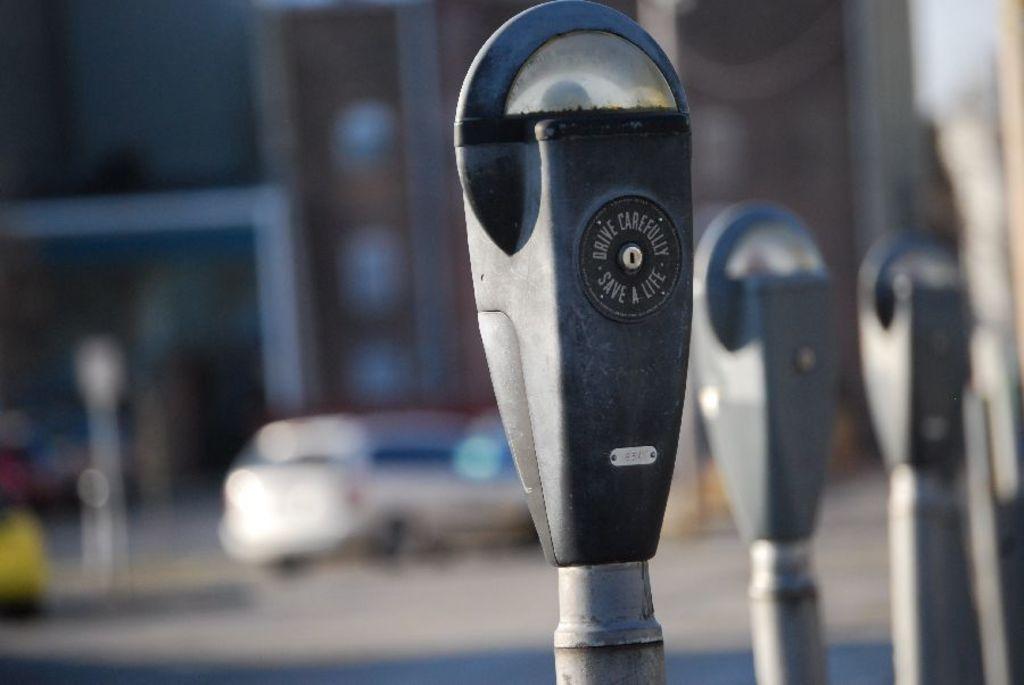Does the meter say to drive carefully?
Keep it short and to the point. Yes. What does the meter say to do safely?
Make the answer very short. Drive. 